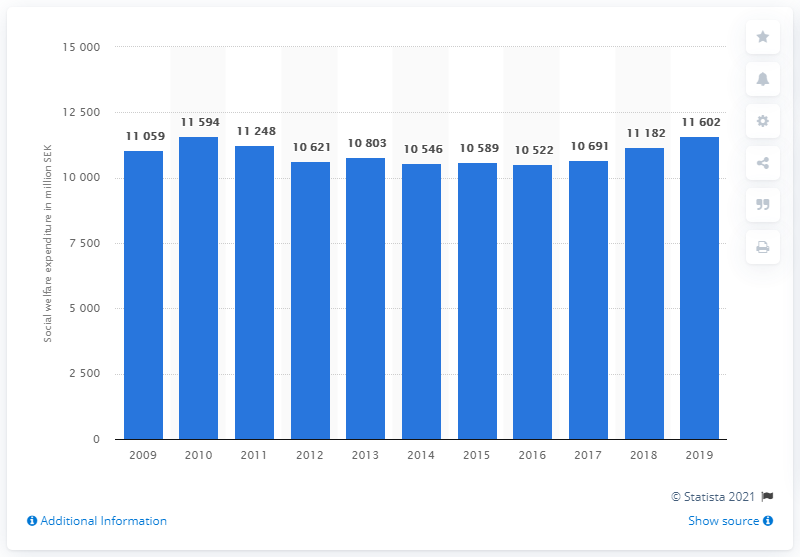Give some essential details in this illustration. In 2019, a total of SEK 11,602 million was spent on social welfare in Sweden. According to the information provided, social welfare expenditure in Sweden reached its highest point in 2010. 